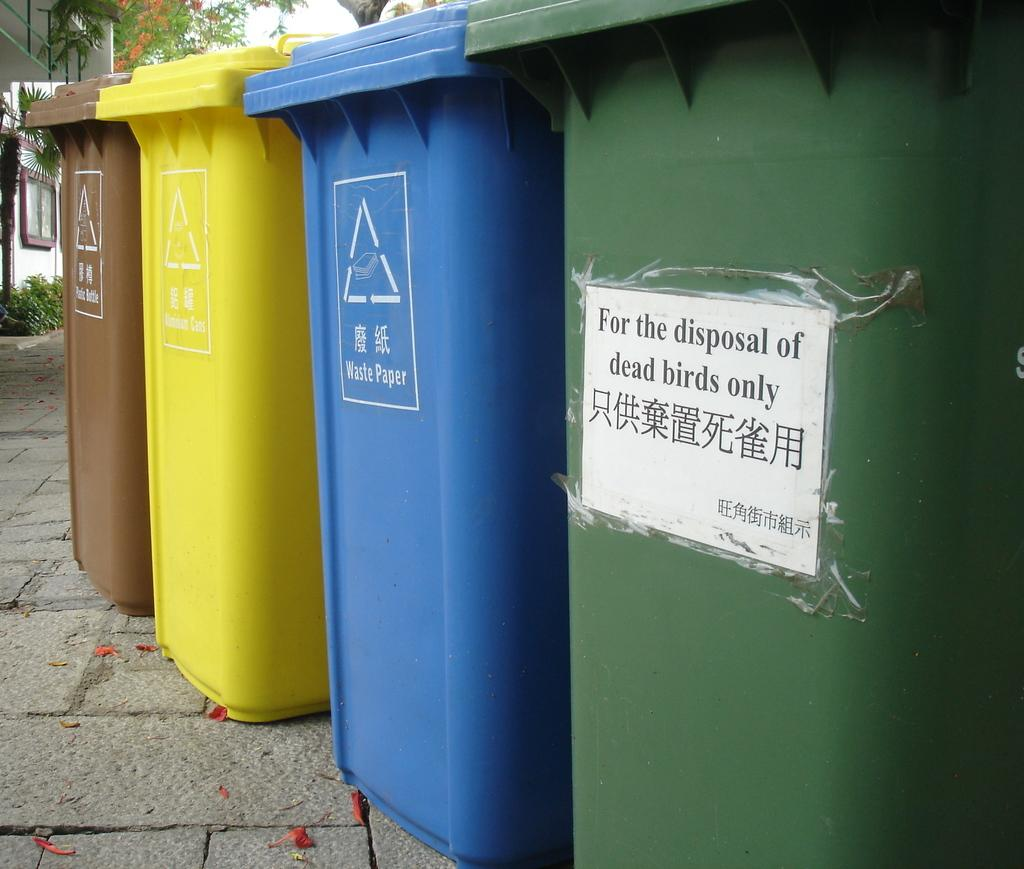Provide a one-sentence caption for the provided image. the four plastic rubbish bins are placed in the street and one of which has the writings of For the disposal of dead birds only. 